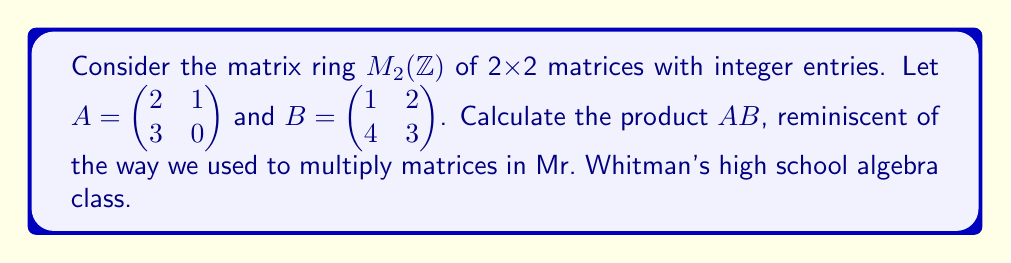Can you solve this math problem? To calculate the product of two matrices in $M_2(\mathbb{Z})$, we use matrix multiplication:

1) The resulting matrix will also be a 2x2 matrix.

2) For each entry in the product matrix:
   - Multiply corresponding elements from the row of A and column of B
   - Sum these products

3) Let's calculate each entry of the product $AB$:

   For the entry in row 1, column 1:
   $$(AB)_{11} = (2 \cdot 1) + (1 \cdot 4) = 2 + 4 = 6$$

   For the entry in row 1, column 2:
   $$(AB)_{12} = (2 \cdot 2) + (1 \cdot 3) = 4 + 3 = 7$$

   For the entry in row 2, column 1:
   $$(AB)_{21} = (3 \cdot 1) + (0 \cdot 4) = 3 + 0 = 3$$

   For the entry in row 2, column 2:
   $$(AB)_{22} = (3 \cdot 2) + (0 \cdot 3) = 6 + 0 = 6$$

4) Therefore, the product matrix is:

   $$AB = \begin{pmatrix} 6 & 7 \\ 3 & 6 \end{pmatrix}$$

This method of matrix multiplication is a fundamental operation in the matrix ring $M_2(\mathbb{Z})$.
Answer: $$AB = \begin{pmatrix} 6 & 7 \\ 3 & 6 \end{pmatrix}$$ 